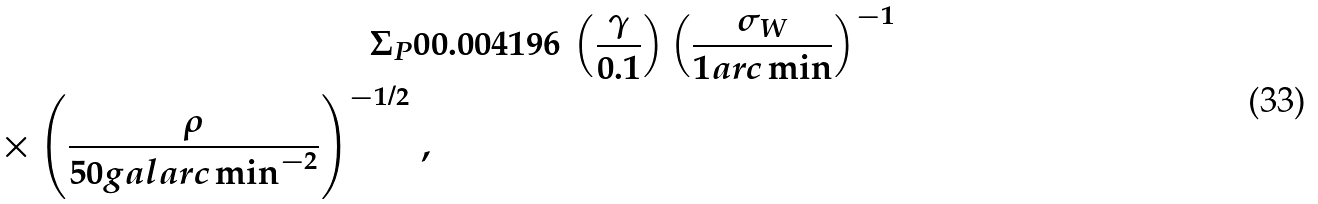<formula> <loc_0><loc_0><loc_500><loc_500>\Sigma _ { P } 0 & 0 . 0 0 4 1 9 6 \, \left ( \frac { \gamma } { 0 . 1 } \right ) \left ( \frac { \sigma _ { W } } { 1 a r c \min } \right ) ^ { - 1 } \\ \times \left ( \frac { \rho } { 5 0 g a l a r c \min ^ { - 2 } } \right ) ^ { - 1 / 2 } \, ,</formula> 